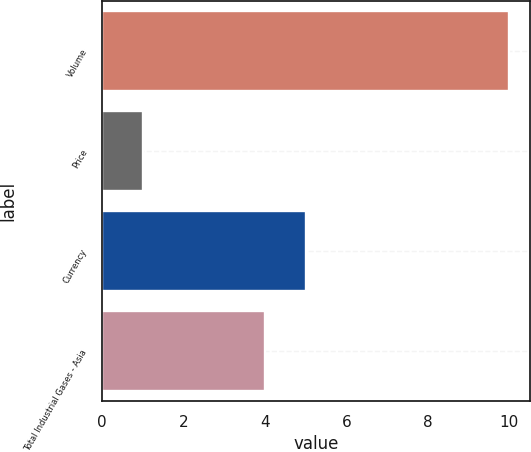Convert chart to OTSL. <chart><loc_0><loc_0><loc_500><loc_500><bar_chart><fcel>Volume<fcel>Price<fcel>Currency<fcel>Total Industrial Gases - Asia<nl><fcel>10<fcel>1<fcel>5<fcel>4<nl></chart> 